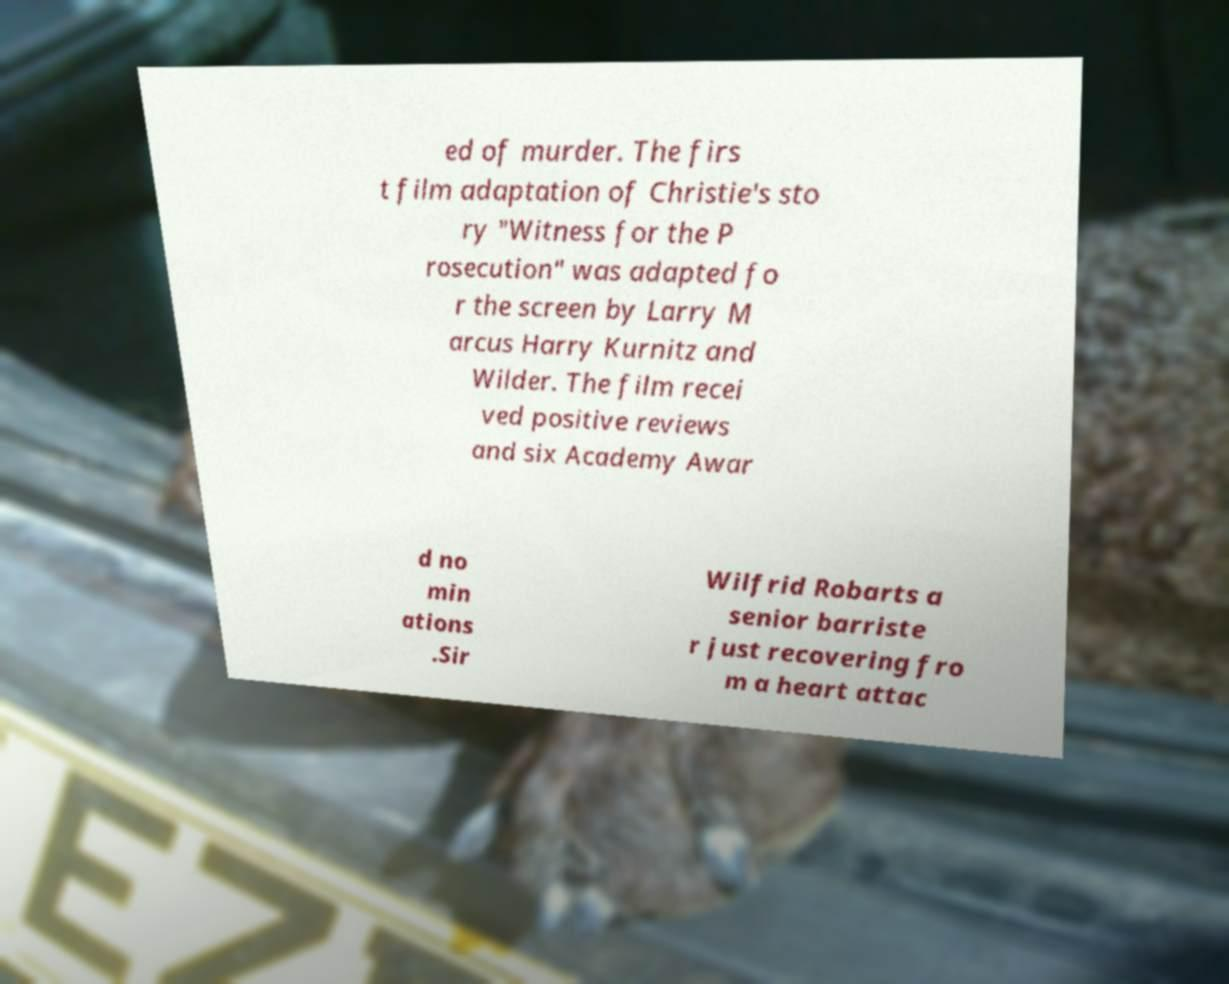What messages or text are displayed in this image? I need them in a readable, typed format. ed of murder. The firs t film adaptation of Christie's sto ry "Witness for the P rosecution" was adapted fo r the screen by Larry M arcus Harry Kurnitz and Wilder. The film recei ved positive reviews and six Academy Awar d no min ations .Sir Wilfrid Robarts a senior barriste r just recovering fro m a heart attac 